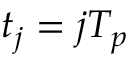<formula> <loc_0><loc_0><loc_500><loc_500>t _ { j } = j T _ { p }</formula> 